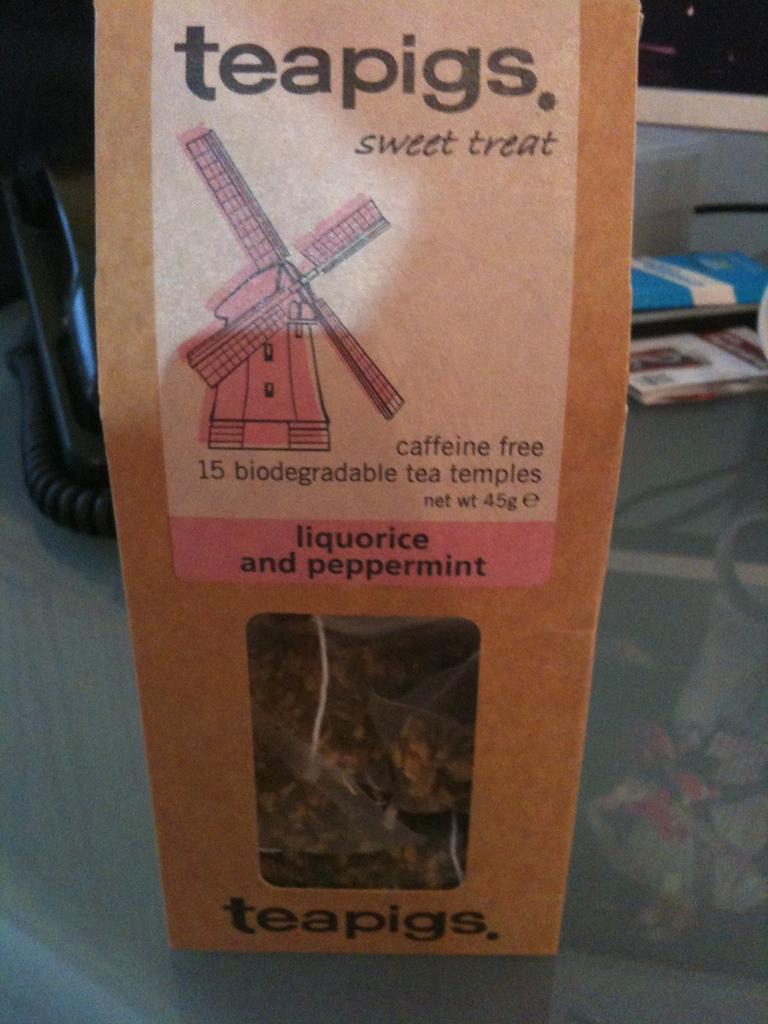Provide a one-sentence caption for the provided image. The type of treats shown are teapigs sweet treats. 